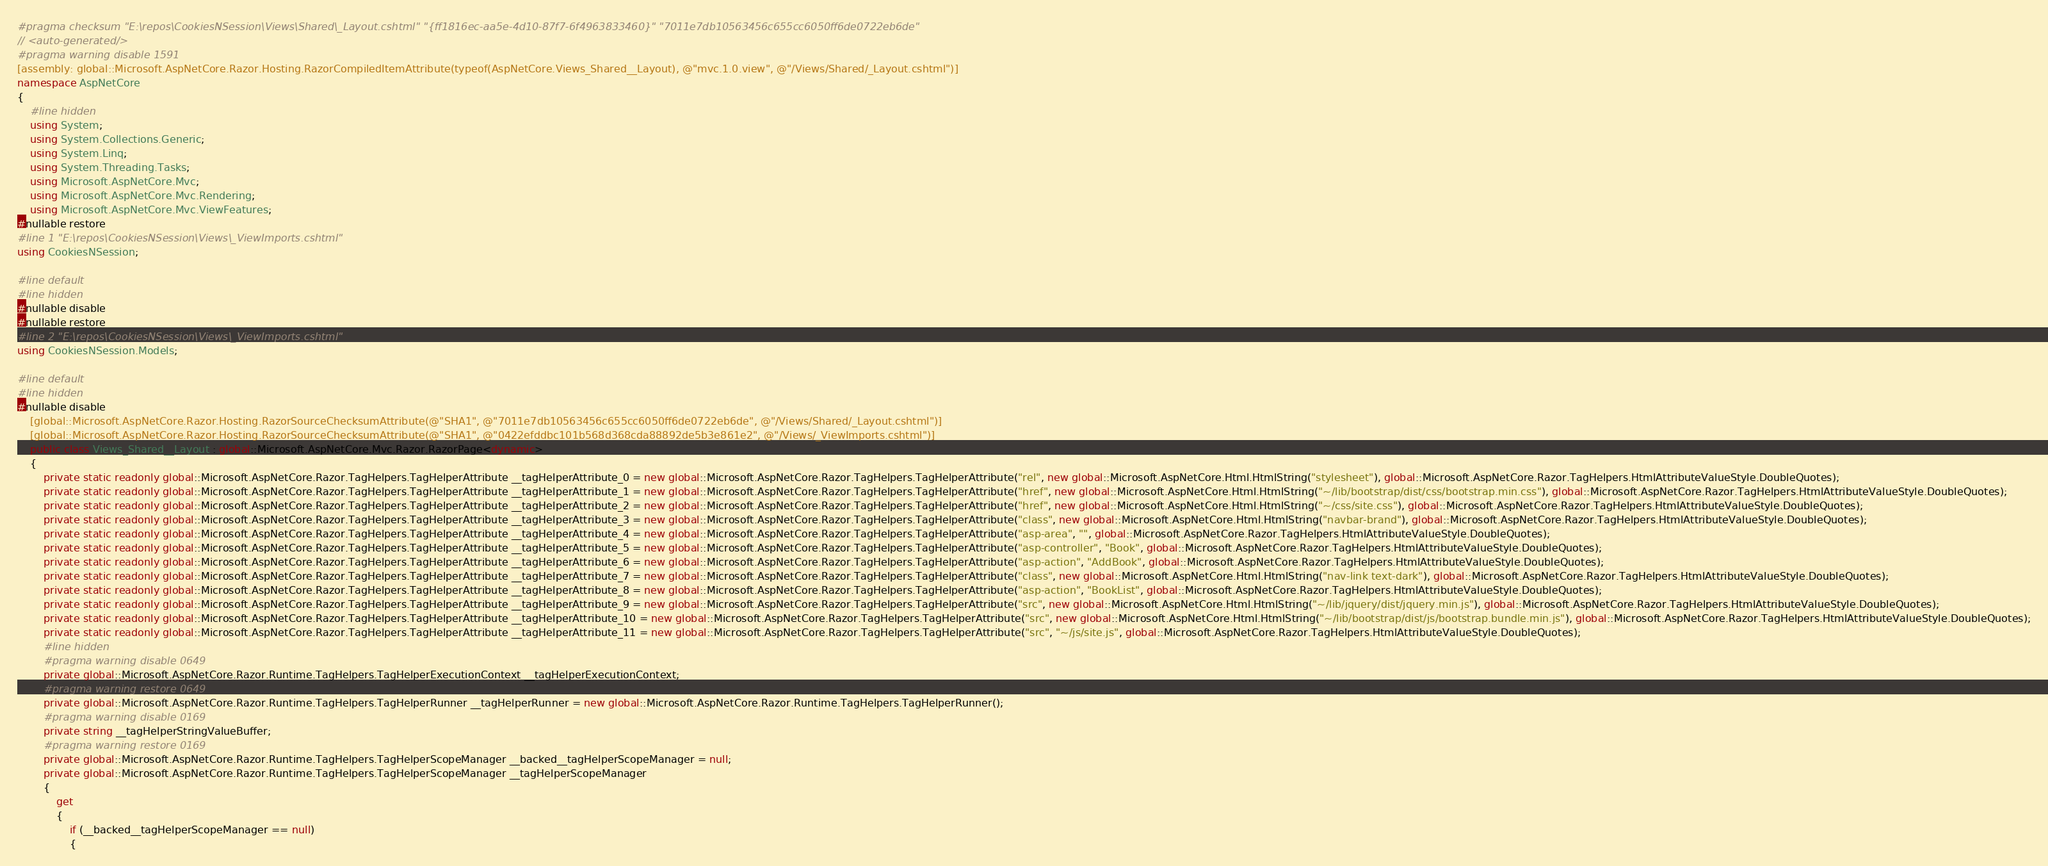<code> <loc_0><loc_0><loc_500><loc_500><_C#_>#pragma checksum "E:\repos\CookiesNSession\Views\Shared\_Layout.cshtml" "{ff1816ec-aa5e-4d10-87f7-6f4963833460}" "7011e7db10563456c655cc6050ff6de0722eb6de"
// <auto-generated/>
#pragma warning disable 1591
[assembly: global::Microsoft.AspNetCore.Razor.Hosting.RazorCompiledItemAttribute(typeof(AspNetCore.Views_Shared__Layout), @"mvc.1.0.view", @"/Views/Shared/_Layout.cshtml")]
namespace AspNetCore
{
    #line hidden
    using System;
    using System.Collections.Generic;
    using System.Linq;
    using System.Threading.Tasks;
    using Microsoft.AspNetCore.Mvc;
    using Microsoft.AspNetCore.Mvc.Rendering;
    using Microsoft.AspNetCore.Mvc.ViewFeatures;
#nullable restore
#line 1 "E:\repos\CookiesNSession\Views\_ViewImports.cshtml"
using CookiesNSession;

#line default
#line hidden
#nullable disable
#nullable restore
#line 2 "E:\repos\CookiesNSession\Views\_ViewImports.cshtml"
using CookiesNSession.Models;

#line default
#line hidden
#nullable disable
    [global::Microsoft.AspNetCore.Razor.Hosting.RazorSourceChecksumAttribute(@"SHA1", @"7011e7db10563456c655cc6050ff6de0722eb6de", @"/Views/Shared/_Layout.cshtml")]
    [global::Microsoft.AspNetCore.Razor.Hosting.RazorSourceChecksumAttribute(@"SHA1", @"0422efddbc101b568d368cda88892de5b3e861e2", @"/Views/_ViewImports.cshtml")]
    public class Views_Shared__Layout : global::Microsoft.AspNetCore.Mvc.Razor.RazorPage<dynamic>
    {
        private static readonly global::Microsoft.AspNetCore.Razor.TagHelpers.TagHelperAttribute __tagHelperAttribute_0 = new global::Microsoft.AspNetCore.Razor.TagHelpers.TagHelperAttribute("rel", new global::Microsoft.AspNetCore.Html.HtmlString("stylesheet"), global::Microsoft.AspNetCore.Razor.TagHelpers.HtmlAttributeValueStyle.DoubleQuotes);
        private static readonly global::Microsoft.AspNetCore.Razor.TagHelpers.TagHelperAttribute __tagHelperAttribute_1 = new global::Microsoft.AspNetCore.Razor.TagHelpers.TagHelperAttribute("href", new global::Microsoft.AspNetCore.Html.HtmlString("~/lib/bootstrap/dist/css/bootstrap.min.css"), global::Microsoft.AspNetCore.Razor.TagHelpers.HtmlAttributeValueStyle.DoubleQuotes);
        private static readonly global::Microsoft.AspNetCore.Razor.TagHelpers.TagHelperAttribute __tagHelperAttribute_2 = new global::Microsoft.AspNetCore.Razor.TagHelpers.TagHelperAttribute("href", new global::Microsoft.AspNetCore.Html.HtmlString("~/css/site.css"), global::Microsoft.AspNetCore.Razor.TagHelpers.HtmlAttributeValueStyle.DoubleQuotes);
        private static readonly global::Microsoft.AspNetCore.Razor.TagHelpers.TagHelperAttribute __tagHelperAttribute_3 = new global::Microsoft.AspNetCore.Razor.TagHelpers.TagHelperAttribute("class", new global::Microsoft.AspNetCore.Html.HtmlString("navbar-brand"), global::Microsoft.AspNetCore.Razor.TagHelpers.HtmlAttributeValueStyle.DoubleQuotes);
        private static readonly global::Microsoft.AspNetCore.Razor.TagHelpers.TagHelperAttribute __tagHelperAttribute_4 = new global::Microsoft.AspNetCore.Razor.TagHelpers.TagHelperAttribute("asp-area", "", global::Microsoft.AspNetCore.Razor.TagHelpers.HtmlAttributeValueStyle.DoubleQuotes);
        private static readonly global::Microsoft.AspNetCore.Razor.TagHelpers.TagHelperAttribute __tagHelperAttribute_5 = new global::Microsoft.AspNetCore.Razor.TagHelpers.TagHelperAttribute("asp-controller", "Book", global::Microsoft.AspNetCore.Razor.TagHelpers.HtmlAttributeValueStyle.DoubleQuotes);
        private static readonly global::Microsoft.AspNetCore.Razor.TagHelpers.TagHelperAttribute __tagHelperAttribute_6 = new global::Microsoft.AspNetCore.Razor.TagHelpers.TagHelperAttribute("asp-action", "AddBook", global::Microsoft.AspNetCore.Razor.TagHelpers.HtmlAttributeValueStyle.DoubleQuotes);
        private static readonly global::Microsoft.AspNetCore.Razor.TagHelpers.TagHelperAttribute __tagHelperAttribute_7 = new global::Microsoft.AspNetCore.Razor.TagHelpers.TagHelperAttribute("class", new global::Microsoft.AspNetCore.Html.HtmlString("nav-link text-dark"), global::Microsoft.AspNetCore.Razor.TagHelpers.HtmlAttributeValueStyle.DoubleQuotes);
        private static readonly global::Microsoft.AspNetCore.Razor.TagHelpers.TagHelperAttribute __tagHelperAttribute_8 = new global::Microsoft.AspNetCore.Razor.TagHelpers.TagHelperAttribute("asp-action", "BookList", global::Microsoft.AspNetCore.Razor.TagHelpers.HtmlAttributeValueStyle.DoubleQuotes);
        private static readonly global::Microsoft.AspNetCore.Razor.TagHelpers.TagHelperAttribute __tagHelperAttribute_9 = new global::Microsoft.AspNetCore.Razor.TagHelpers.TagHelperAttribute("src", new global::Microsoft.AspNetCore.Html.HtmlString("~/lib/jquery/dist/jquery.min.js"), global::Microsoft.AspNetCore.Razor.TagHelpers.HtmlAttributeValueStyle.DoubleQuotes);
        private static readonly global::Microsoft.AspNetCore.Razor.TagHelpers.TagHelperAttribute __tagHelperAttribute_10 = new global::Microsoft.AspNetCore.Razor.TagHelpers.TagHelperAttribute("src", new global::Microsoft.AspNetCore.Html.HtmlString("~/lib/bootstrap/dist/js/bootstrap.bundle.min.js"), global::Microsoft.AspNetCore.Razor.TagHelpers.HtmlAttributeValueStyle.DoubleQuotes);
        private static readonly global::Microsoft.AspNetCore.Razor.TagHelpers.TagHelperAttribute __tagHelperAttribute_11 = new global::Microsoft.AspNetCore.Razor.TagHelpers.TagHelperAttribute("src", "~/js/site.js", global::Microsoft.AspNetCore.Razor.TagHelpers.HtmlAttributeValueStyle.DoubleQuotes);
        #line hidden
        #pragma warning disable 0649
        private global::Microsoft.AspNetCore.Razor.Runtime.TagHelpers.TagHelperExecutionContext __tagHelperExecutionContext;
        #pragma warning restore 0649
        private global::Microsoft.AspNetCore.Razor.Runtime.TagHelpers.TagHelperRunner __tagHelperRunner = new global::Microsoft.AspNetCore.Razor.Runtime.TagHelpers.TagHelperRunner();
        #pragma warning disable 0169
        private string __tagHelperStringValueBuffer;
        #pragma warning restore 0169
        private global::Microsoft.AspNetCore.Razor.Runtime.TagHelpers.TagHelperScopeManager __backed__tagHelperScopeManager = null;
        private global::Microsoft.AspNetCore.Razor.Runtime.TagHelpers.TagHelperScopeManager __tagHelperScopeManager
        {
            get
            {
                if (__backed__tagHelperScopeManager == null)
                {</code> 